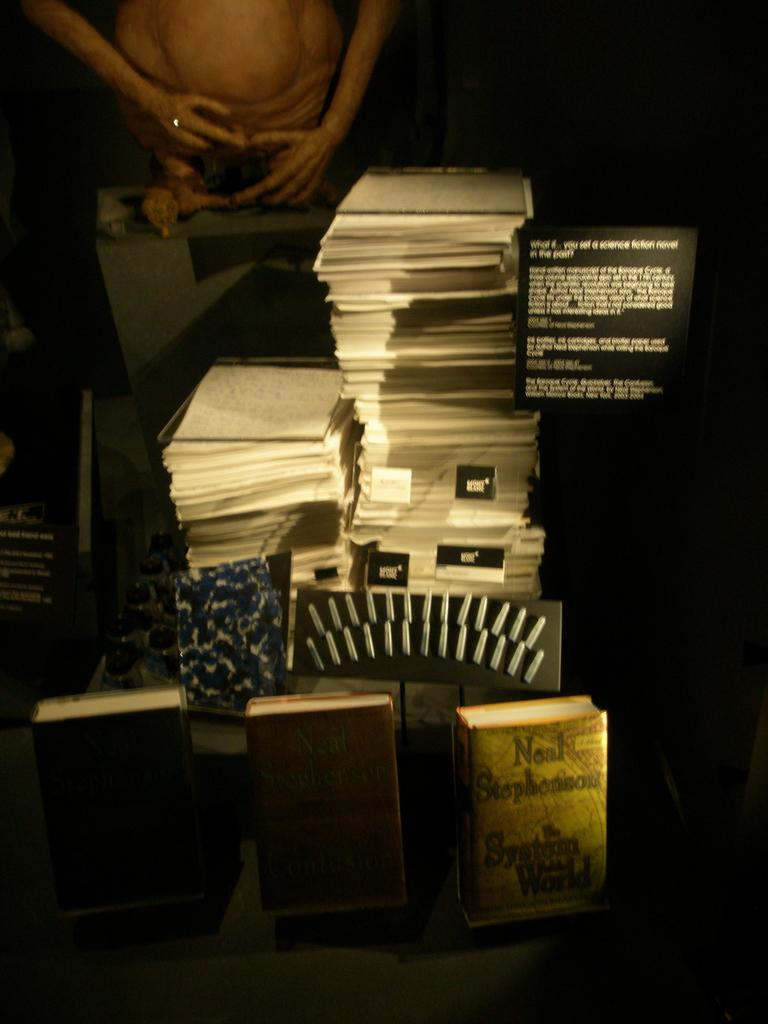<image>
Share a concise interpretation of the image provided. on the table are many documents and a book with the name Neal on it. 